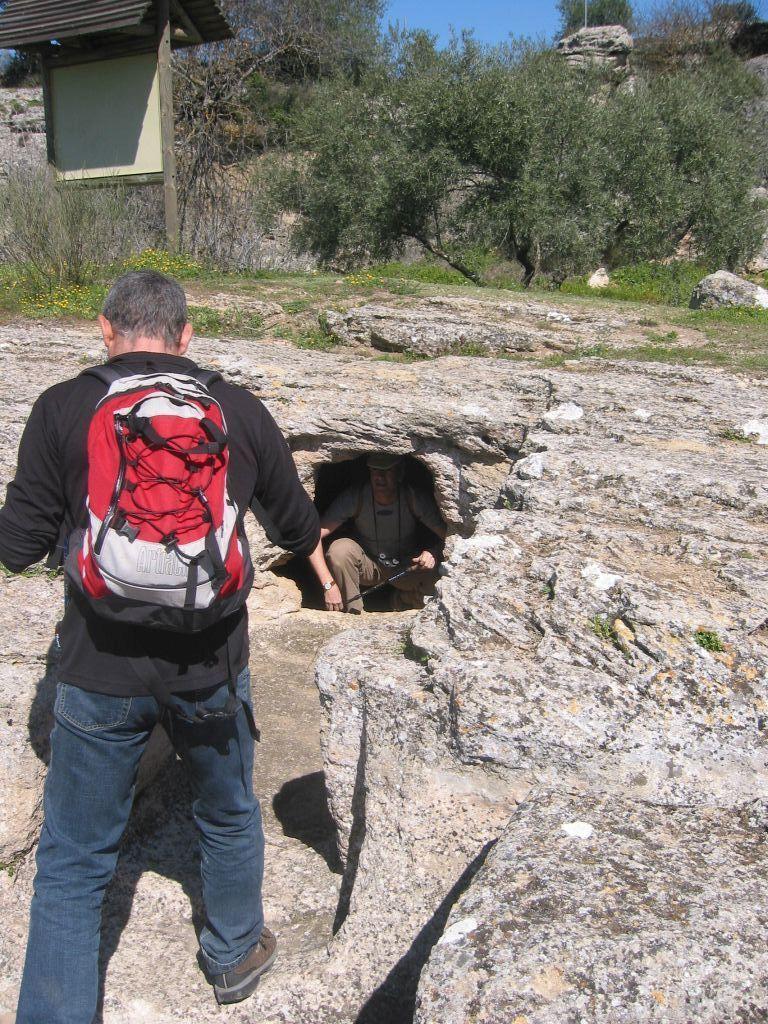How would you summarize this image in a sentence or two? In this image, there is an outside view. There is a person standing and wearing a bag. There are some trees at the top of this picture. There is a person in the center of the image sitting inside the cave. 